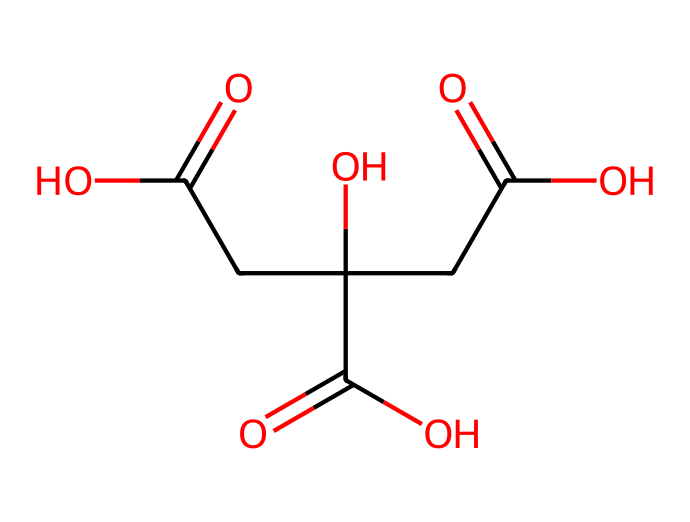How many carbon atoms are in citric acid? By examining the SMILES representation, we count the number of carbon atoms indicated by "C". In this chemical, there are a total of six carbon atoms.
Answer: six What type of functional groups are present in citric acid? In the SMILES structure, the presence of -COOH groups indicates that there are carboxylic acid functional groups. This molecule has three -COOH groups, which defines its acidic properties.
Answer: carboxylic acids How many hydroxyl (-OH) groups are found in the structural representation of citric acid? The -OH groups in the SMILES are represented by the "O" that follows the "C" atoms. In this molecule, there are one -OH group.
Answer: one What is the total number of double bonds in citric acid? The number of double bonds can be determined by looking for "=" in the SMILES notation. In citric acid, there are three double bonds (two carbonyl groups and one between the last carbon and oxygen).
Answer: three Why is citric acid considered a weak acid? Citric acid, although it has multiple carboxylic acid groups, does not fully dissociate in solution, defining it as a weak acid because of its relatively higher pH in aqueous solutions compared to strong acids.
Answer: weak acid 